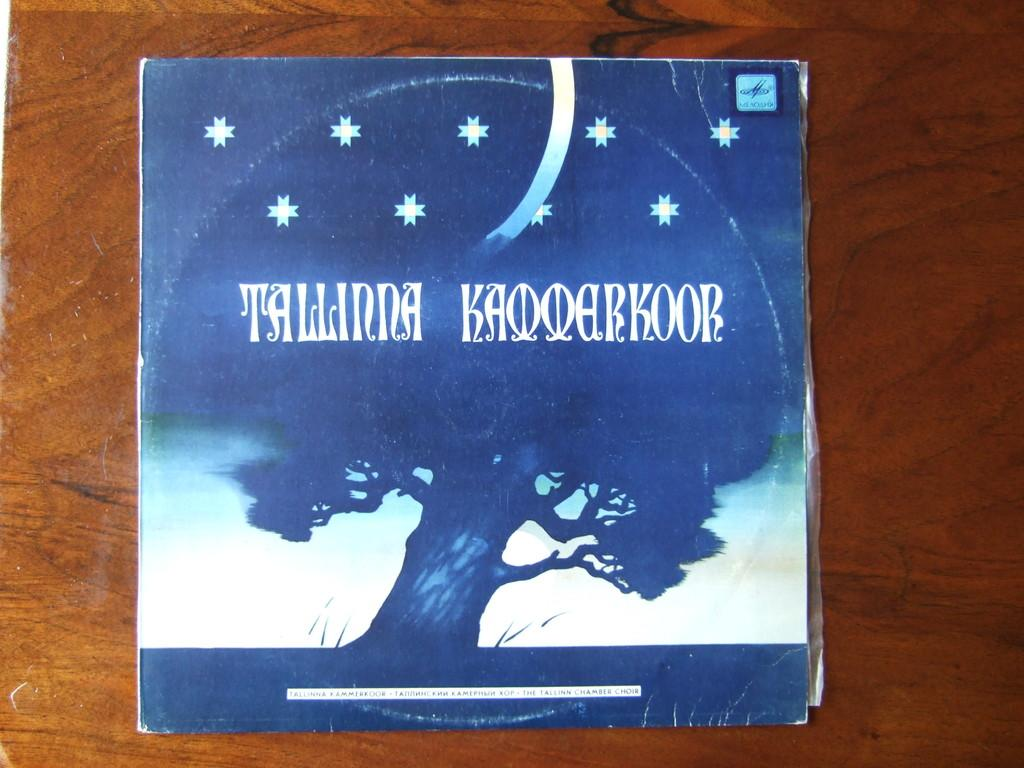<image>
Render a clear and concise summary of the photo. A cover with the words Tallinna Kaooarkoor written on it. 